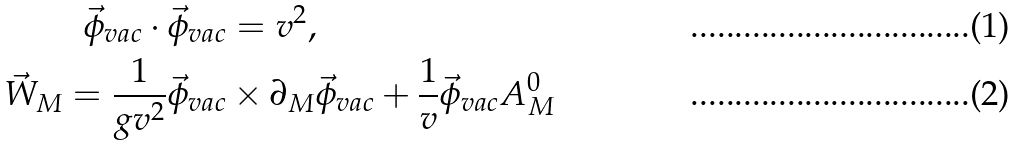<formula> <loc_0><loc_0><loc_500><loc_500>\vec { \phi } _ { v a c } \cdot \vec { \phi } _ { v a c } & = v ^ { 2 } , \\ \vec { W } _ { M } = \frac { 1 } { g v ^ { 2 } } \vec { \phi } _ { v a c } & \times \partial _ { M } \vec { \phi } _ { v a c } + \frac { 1 } { v } \vec { \phi } _ { v a c } A ^ { 0 } _ { M }</formula> 